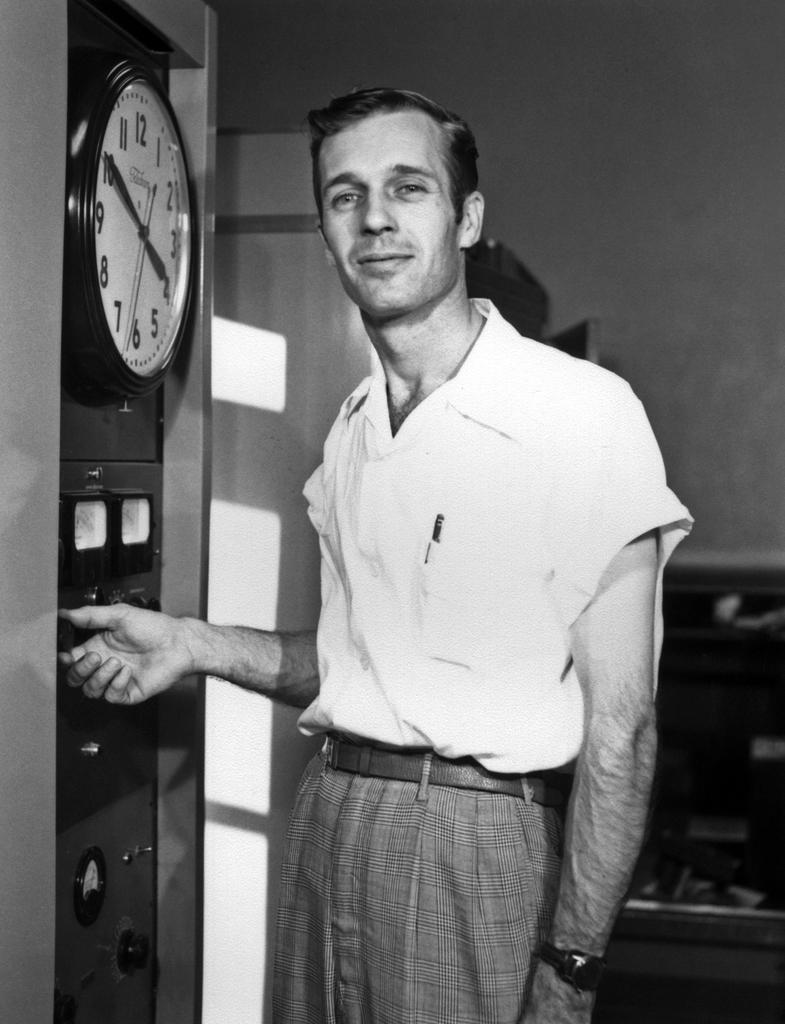Is there a coors light pool party?
Your answer should be very brief. No. What number does the small hand point to?
Provide a short and direct response. 4. 